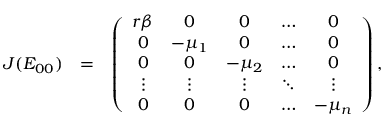<formula> <loc_0><loc_0><loc_500><loc_500>\begin{array} { r l r } { J ( E _ { 0 0 } ) } & { = } & { \left ( \begin{array} { c c c c c } { r \beta } & { 0 } & { 0 } & { \hdots } & { 0 } \\ { 0 } & { - \mu _ { 1 } } & { 0 } & { \hdots } & { 0 } \\ { 0 } & { 0 } & { - \mu _ { 2 } } & { \hdots } & { 0 } \\ { \vdots } & { \vdots } & { \vdots } & { \ddots } & { \vdots } \\ { 0 } & { 0 } & { 0 } & { \hdots } & { - \mu _ { n } } \end{array} \right ) , } \end{array}</formula> 